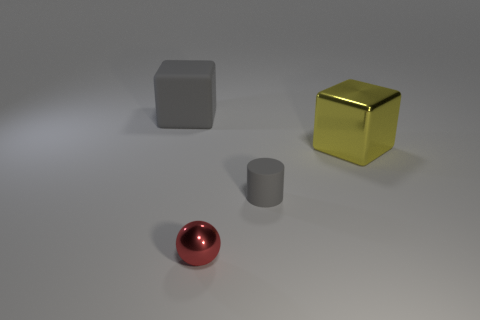There is a object that is the same color as the cylinder; what shape is it?
Keep it short and to the point. Cube. There is a shiny thing that is behind the small shiny ball; what color is it?
Give a very brief answer. Yellow. How many things are either metallic objects that are on the left side of the tiny gray thing or green matte spheres?
Provide a succinct answer. 1. What color is the matte object that is the same size as the metal block?
Your answer should be compact. Gray. Are there more large yellow metal cubes to the left of the large gray matte object than large yellow metallic things?
Your response must be concise. No. The object that is both on the left side of the gray rubber cylinder and in front of the big gray object is made of what material?
Provide a short and direct response. Metal. Does the metallic object left of the shiny cube have the same color as the rubber object behind the small rubber cylinder?
Make the answer very short. No. What number of other objects are the same size as the gray cylinder?
Your answer should be very brief. 1. There is a cube behind the cube on the right side of the red shiny ball; is there a matte block that is left of it?
Offer a very short reply. No. Is the material of the block that is on the left side of the red sphere the same as the sphere?
Your response must be concise. No. 